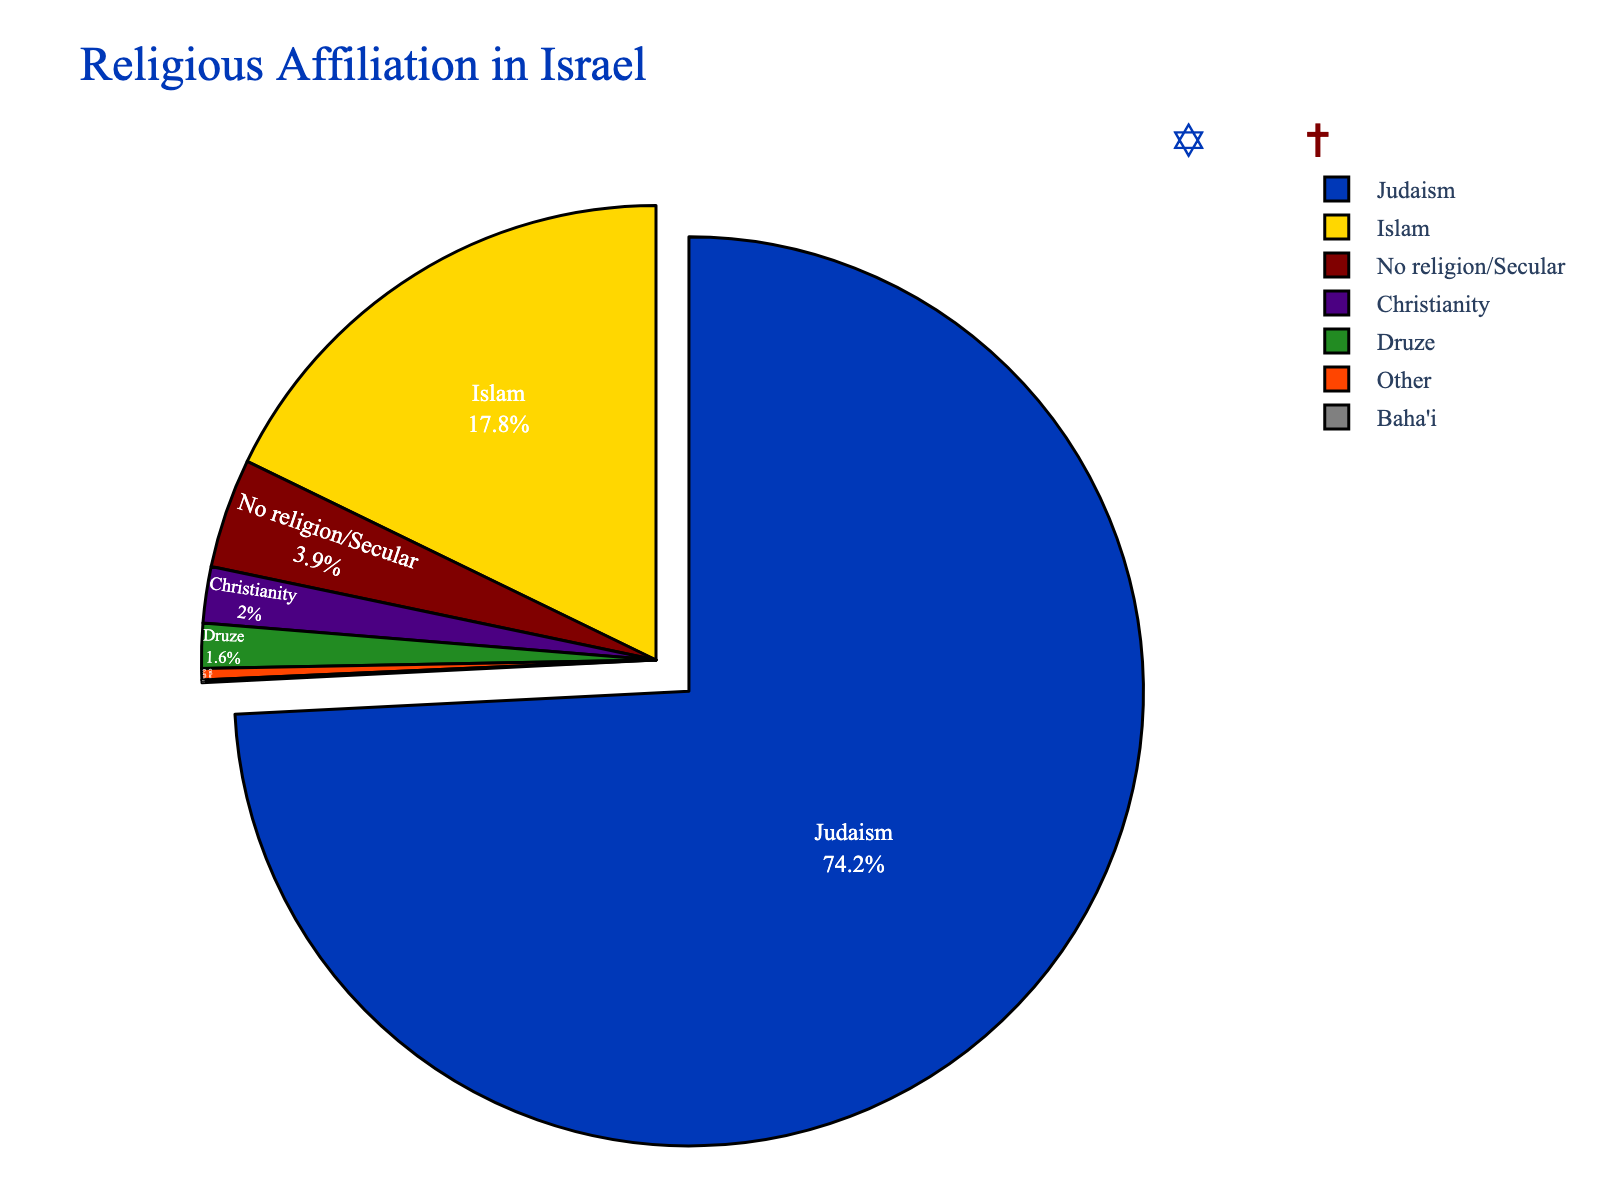What percentage of the population practices Judaism or Christianity? Sum the percentages of Judaism and Christianity: 74.2% + 2.0% which equals 76.2%.
Answer: 76.2% Which faith group has the smallest representation? Look at the percentages and identify that Baha'i has the smallest value at 0.1%.
Answer: Baha'i What is the difference in representation between Islam and No Religion/Secular groups? Subtract the percentage of No Religion/Secular from the percentage of Islam: 17.8% - 3.9% which equals 13.9%.
Answer: 13.9% How much larger is the percentage of Druze compared to the percentage of Baha'i? Subtract the percentage of Baha'i from the percentage of Druze: 1.6% - 0.1% which equals 1.5%.
Answer: 1.5% By how much does the percentage of the Jewish population exceed the combined percentage of all other faith groups? First, sum the percentages of all other groups (Islam, Christianity, Druze, Baha'i, Other, No religion/Secular): 17.8% + 2.0% + 1.6% + 0.1% + 0.4% + 3.9% which equals 25.8%. Then, subtract this sum from the percentage of the Jewish population: 74.2% - 25.8% which equals 48.4%.
Answer: 48.4% Which groups are represented by blue and green colors respectively? Based on the palette inspired by religious symbolism, blue represents Judaism and green represents Druze.
Answer: Judaism and Druze Compare the combined percentage of Christians and Baha'i to the percentage of those with no religion/secular. Add the percentages of Christianity and Baha'i: 2.0% + 0.1% which equals 2.1%, and compare it to the percentage of No religion/Secular which is 3.9%. Hence, 3.9% is greater.
Answer: No religion/Secular What is the average percentage of the faith groups Islam, Christianity, and Druze? Sum the percentages of Islam, Christianity, and Druze: 17.8% + 2.0% + 1.6% which equals 21.4%. Divide by 3 to get the average: 21.4% / 3 which is approximately 7.13%.
Answer: 7.13% 